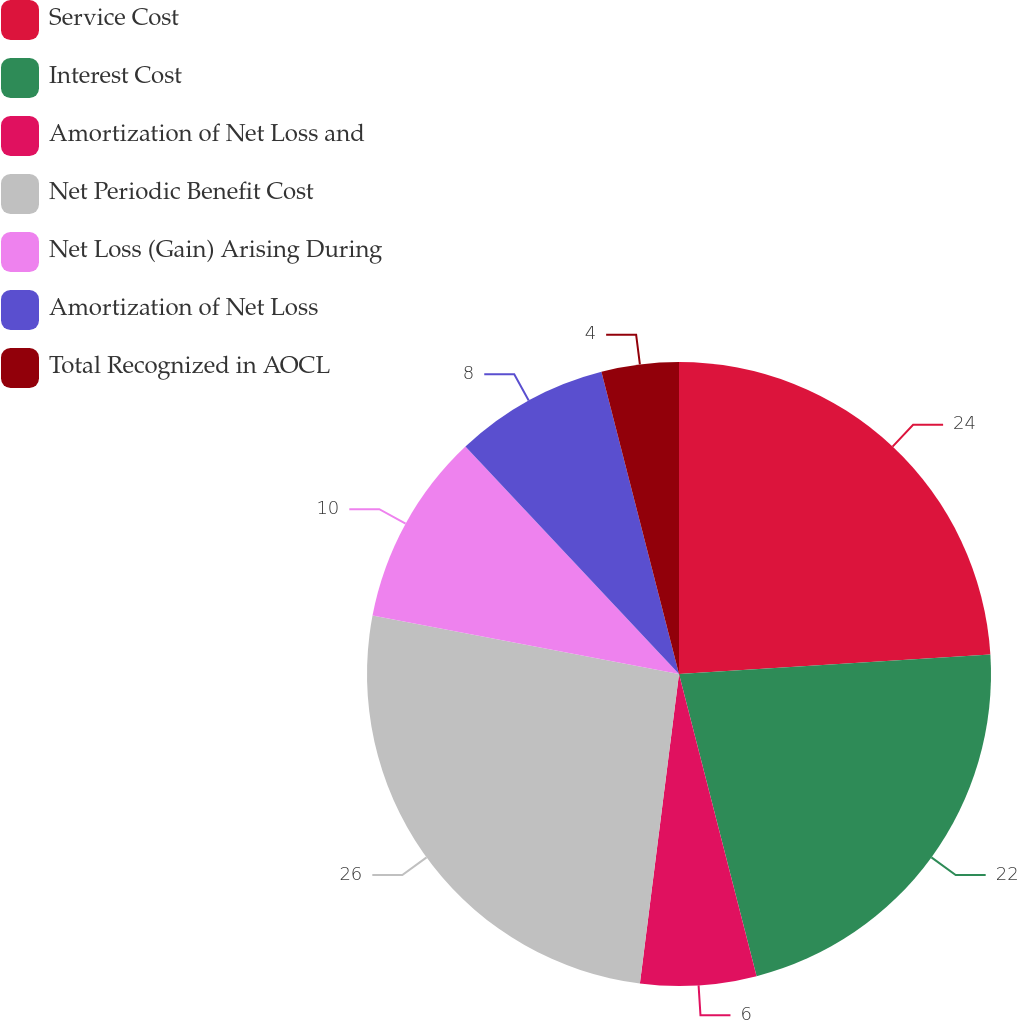<chart> <loc_0><loc_0><loc_500><loc_500><pie_chart><fcel>Service Cost<fcel>Interest Cost<fcel>Amortization of Net Loss and<fcel>Net Periodic Benefit Cost<fcel>Net Loss (Gain) Arising During<fcel>Amortization of Net Loss<fcel>Total Recognized in AOCL<nl><fcel>24.0%<fcel>22.0%<fcel>6.0%<fcel>26.0%<fcel>10.0%<fcel>8.0%<fcel>4.0%<nl></chart> 